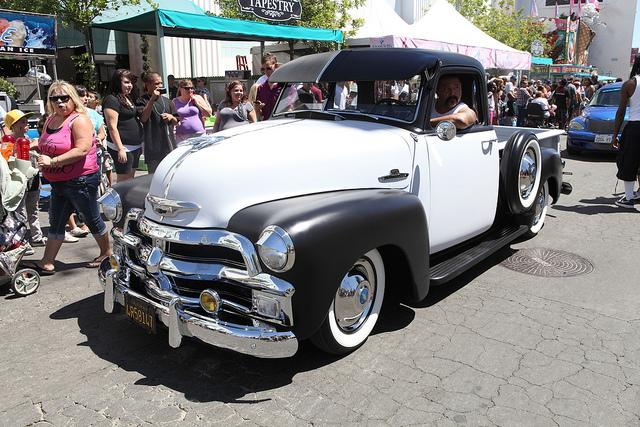Where Tapestry is located? store 